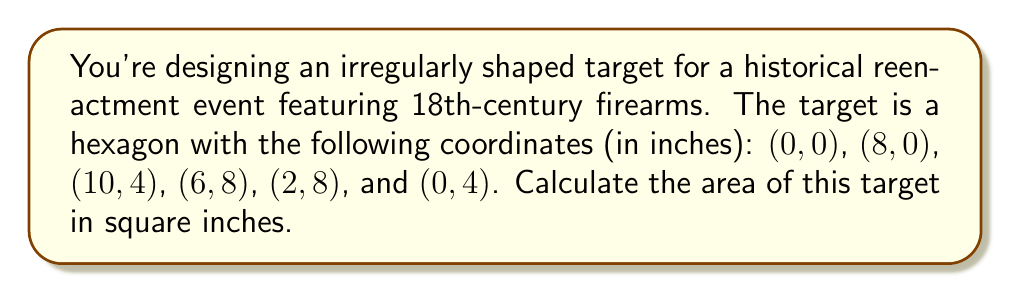Give your solution to this math problem. To find the area of this irregular hexagon, we can use the Shoelace formula (also known as the surveyor's formula). The steps are as follows:

1) List the coordinates in order, repeating the first coordinate at the end:
   $(x_1,y_1) = (0,0)$
   $(x_2,y_2) = (8,0)$
   $(x_3,y_3) = (10,4)$
   $(x_4,y_4) = (6,8)$
   $(x_5,y_5) = (2,8)$
   $(x_6,y_6) = (0,4)$
   $(x_7,y_7) = (0,0)$

2) Apply the Shoelace formula:
   $$A = \frac{1}{2}|\sum_{i=1}^{n} (x_iy_{i+1} - x_{i+1}y_i)|$$

3) Calculate each term:
   $x_1y_2 - x_2y_1 = 0 \cdot 0 - 8 \cdot 0 = 0$
   $x_2y_3 - x_3y_2 = 8 \cdot 4 - 10 \cdot 0 = 32$
   $x_3y_4 - x_4y_3 = 10 \cdot 8 - 6 \cdot 4 = 56$
   $x_4y_5 - x_5y_4 = 6 \cdot 8 - 2 \cdot 8 = 32$
   $x_5y_6 - x_6y_5 = 2 \cdot 4 - 0 \cdot 8 = 8$
   $x_6y_7 - x_7y_6 = 0 \cdot 0 - 0 \cdot 4 = 0$

4) Sum these terms:
   $0 + 32 + 56 + 32 + 8 + 0 = 128$

5) Multiply by $\frac{1}{2}$:
   $$A = \frac{1}{2} \cdot 128 = 64$$

Therefore, the area of the irregular hexagonal target is 64 square inches.

[asy]
unitsize(10mm);
draw((0,0)--(8,0)--(10,4)--(6,8)--(2,8)--(0,4)--cycle);
label("(0,0)", (0,0), SW);
label("(8,0)", (8,0), SE);
label("(10,4)", (10,4), E);
label("(6,8)", (6,8), NE);
label("(2,8)", (2,8), NW);
label("(0,4)", (0,4), W);
[/asy]
Answer: 64 sq in 